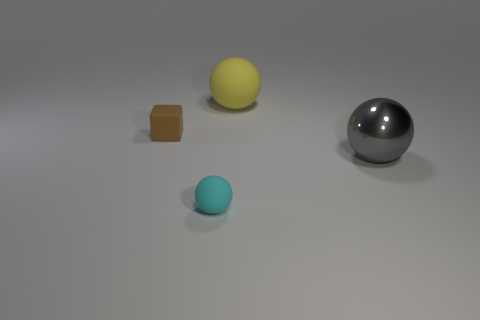Add 3 gray cubes. How many objects exist? 7 Subtract all balls. How many objects are left? 1 Subtract all big metallic balls. Subtract all yellow metal blocks. How many objects are left? 3 Add 2 large metallic spheres. How many large metallic spheres are left? 3 Add 3 tiny green objects. How many tiny green objects exist? 3 Subtract 0 purple blocks. How many objects are left? 4 